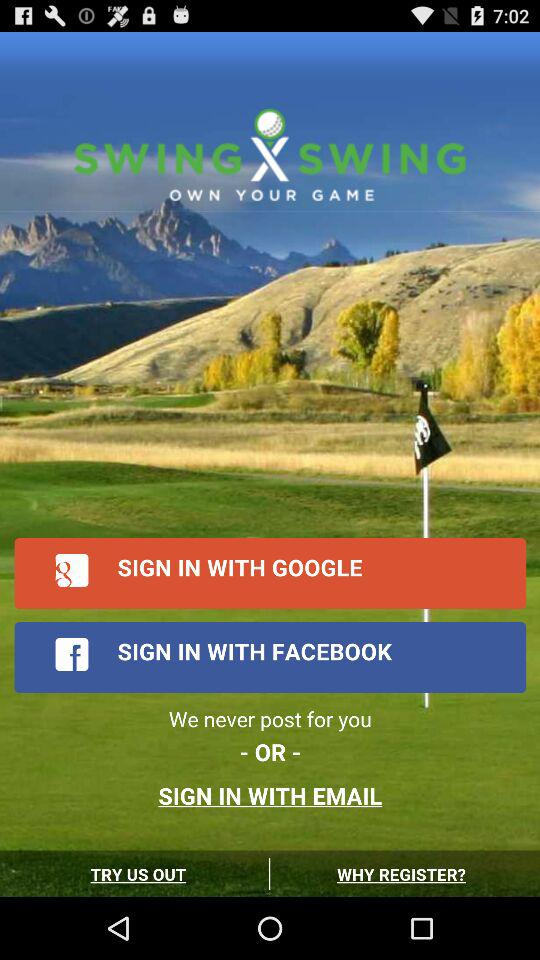Through what applications can we sign in with? You can sign in with "SIGN IN WITH GOOGLE", "SIGN IN WITH FACEBOOK", and "SIGN IN WITH EMAIL". 